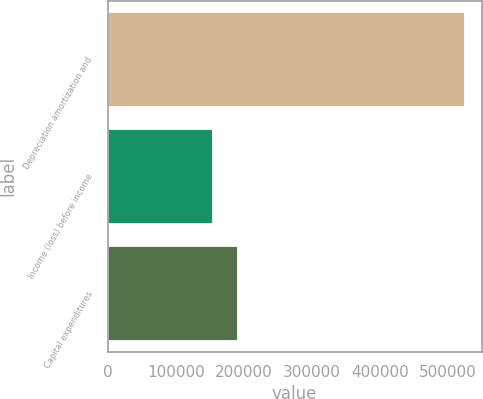Convert chart. <chart><loc_0><loc_0><loc_500><loc_500><bar_chart><fcel>Depreciation amortization and<fcel>Income (loss) before income<fcel>Capital expenditures<nl><fcel>522928<fcel>152840<fcel>189849<nl></chart> 